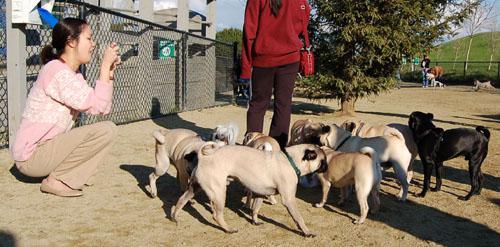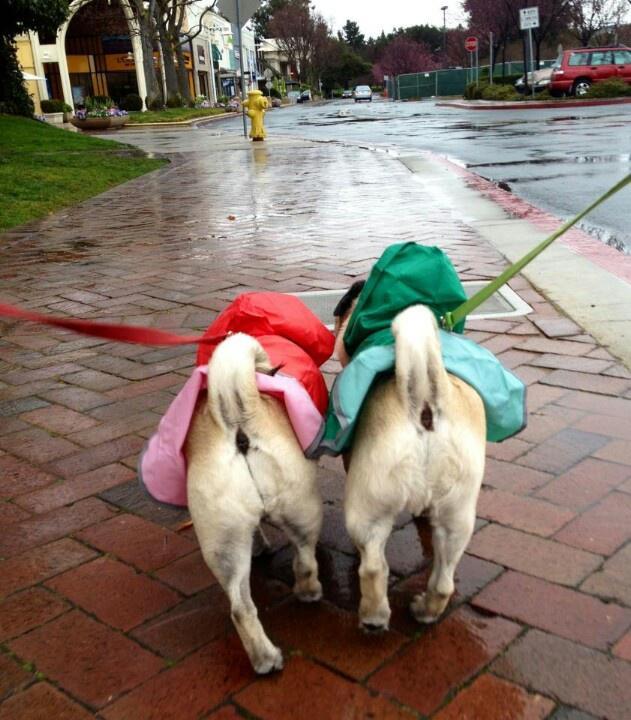The first image is the image on the left, the second image is the image on the right. Examine the images to the left and right. Is the description "The left image contains no more than one dog." accurate? Answer yes or no. No. The first image is the image on the left, the second image is the image on the right. Considering the images on both sides, is "One image shows a pug sitting, with its hind legs extended, on cement next to something made of metal." valid? Answer yes or no. No. 